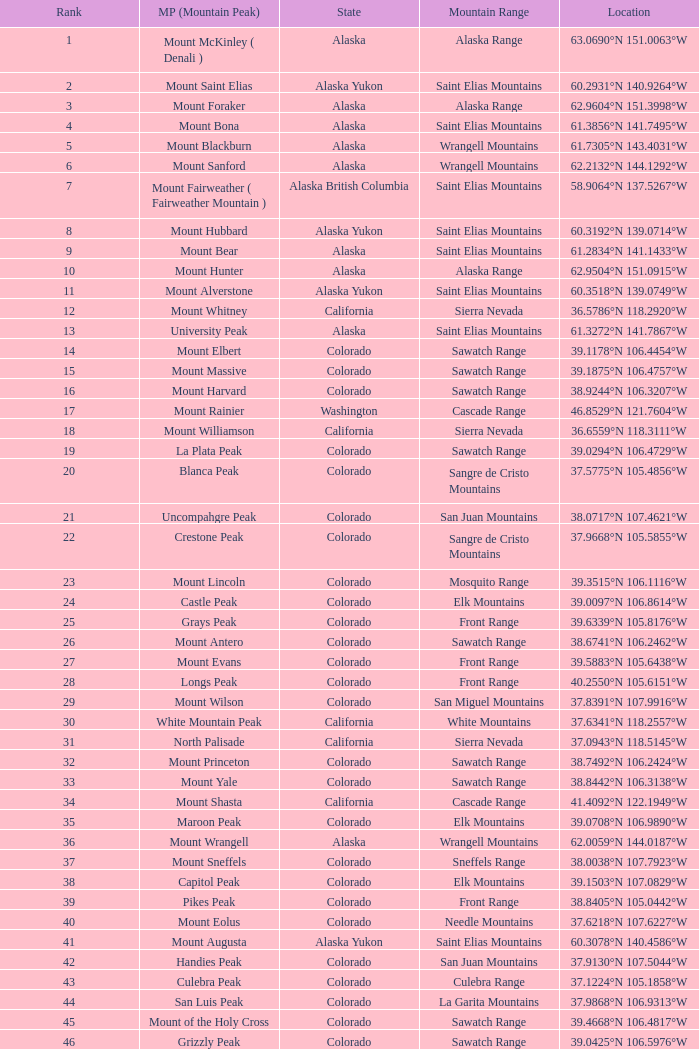What is the mountain range when the state is colorado, rank is higher than 90 and mountain peak is whetstone mountain? West Elk Mountains. 